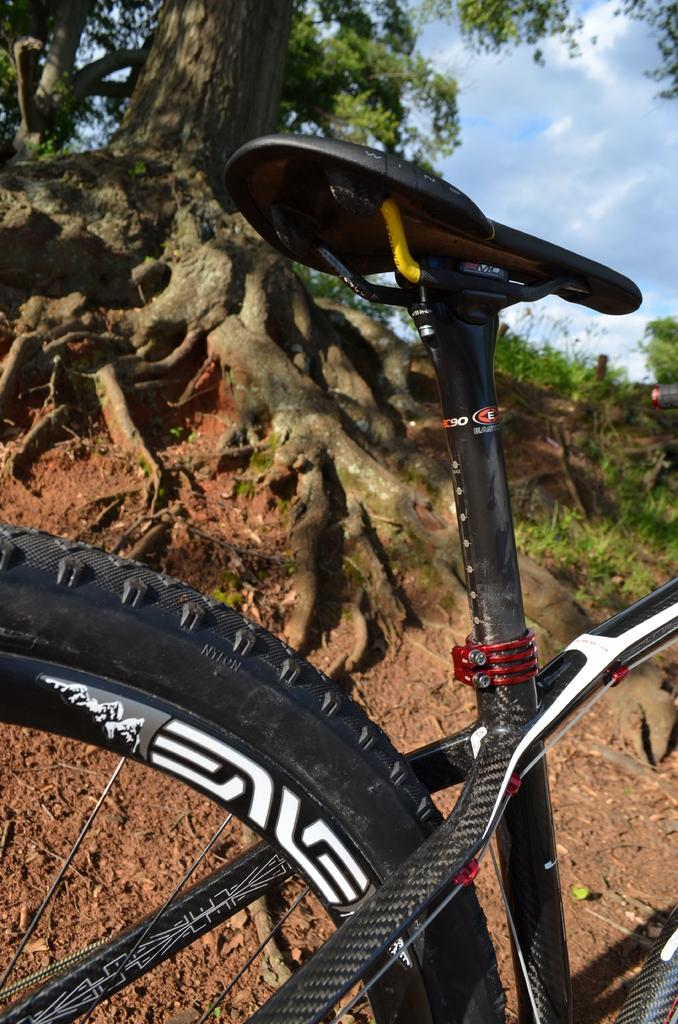What is the main object in the foreground of the image? There is a bicycle in the foreground of the image. What type of natural environment is visible in the image? Trees, grass, and the sky are visible in the image. What is the condition of the sky in the image? The sky is visible in the image, and there are clouds present. What type of terrain is at the bottom of the image? Grass and mud are visible at the bottom of the image. How many babies are crawling on the bicycle in the image? There are no babies present in the image, and therefore no babies are crawling on the bicycle. What type of clocks can be seen hanging from the trees in the image? There are no clocks visible in the image, as it features a bicycle, trees, grass, mud, and the sky. 